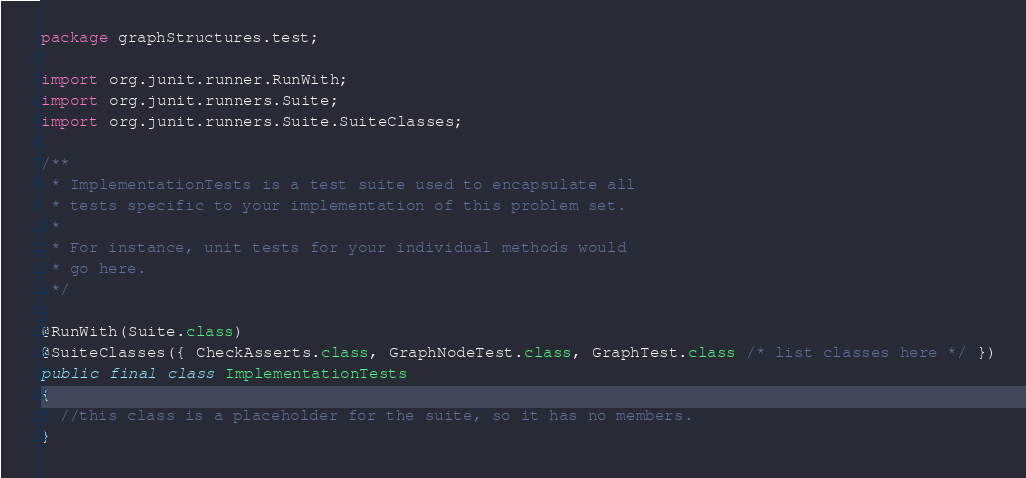<code> <loc_0><loc_0><loc_500><loc_500><_Java_>
package graphStructures.test;

import org.junit.runner.RunWith;
import org.junit.runners.Suite;
import org.junit.runners.Suite.SuiteClasses;

/**
 * ImplementationTests is a test suite used to encapsulate all
 * tests specific to your implementation of this problem set.
 *
 * For instance, unit tests for your individual methods would
 * go here.
 */

@RunWith(Suite.class)
@SuiteClasses({ CheckAsserts.class, GraphNodeTest.class, GraphTest.class /* list classes here */ })
public final class ImplementationTests
{
  //this class is a placeholder for the suite, so it has no members.
}

</code> 